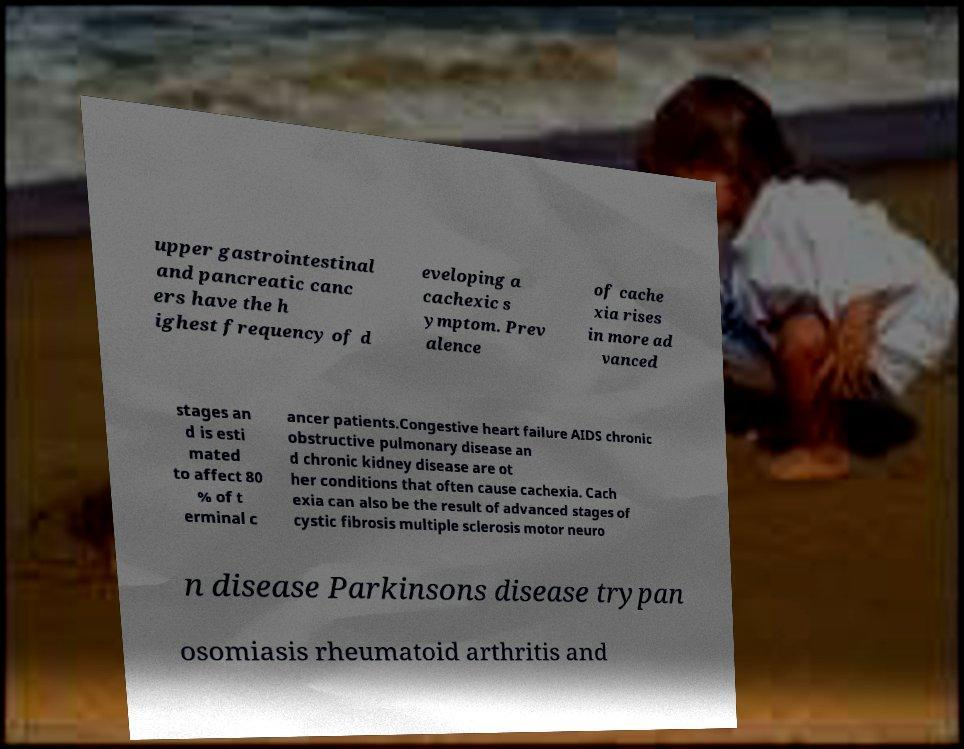Can you accurately transcribe the text from the provided image for me? upper gastrointestinal and pancreatic canc ers have the h ighest frequency of d eveloping a cachexic s ymptom. Prev alence of cache xia rises in more ad vanced stages an d is esti mated to affect 80 % of t erminal c ancer patients.Congestive heart failure AIDS chronic obstructive pulmonary disease an d chronic kidney disease are ot her conditions that often cause cachexia. Cach exia can also be the result of advanced stages of cystic fibrosis multiple sclerosis motor neuro n disease Parkinsons disease trypan osomiasis rheumatoid arthritis and 